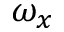<formula> <loc_0><loc_0><loc_500><loc_500>\omega _ { x }</formula> 